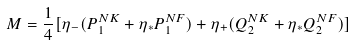Convert formula to latex. <formula><loc_0><loc_0><loc_500><loc_500>M = \frac { 1 } { 4 } [ \eta _ { - } ( P _ { 1 } ^ { N K } + \eta _ { * } P _ { 1 } ^ { N F } ) + \eta _ { + } ( Q _ { 2 } ^ { N K } + \eta _ { * } Q _ { 2 } ^ { N F } ) ]</formula> 